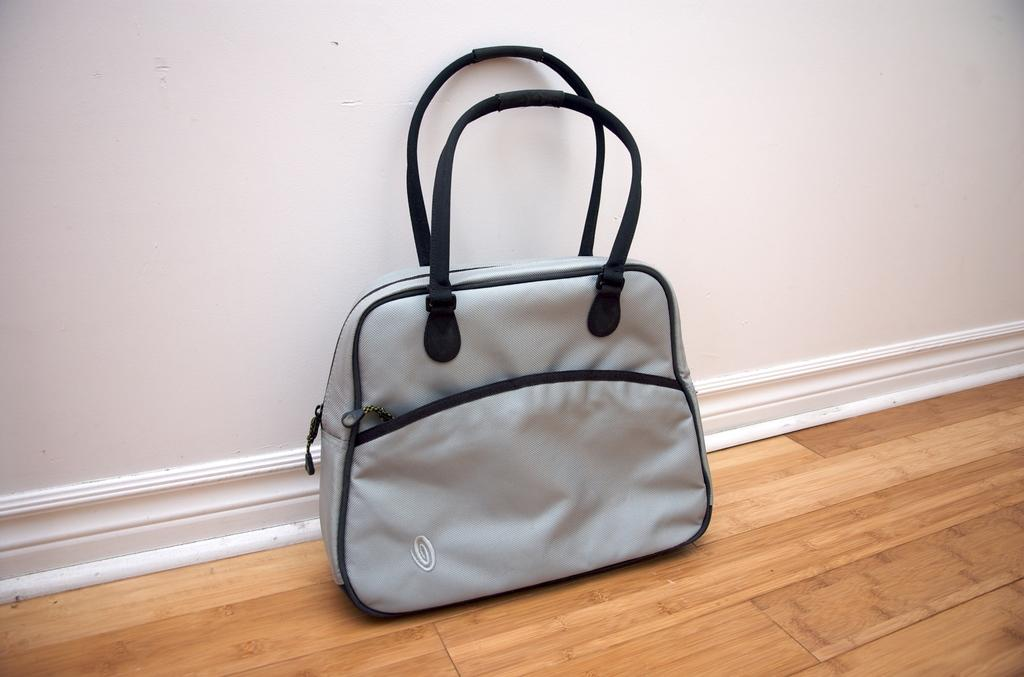What object is placed on the floor in the image? There is a handbag placed on the floor in the image. What is the color of the handbag? The handbag is grey and black in color. What type of shirt is visible on the handbag in the image? There is no shirt visible on the handbag in the image, as it is a handbag and not a person wearing a shirt. 